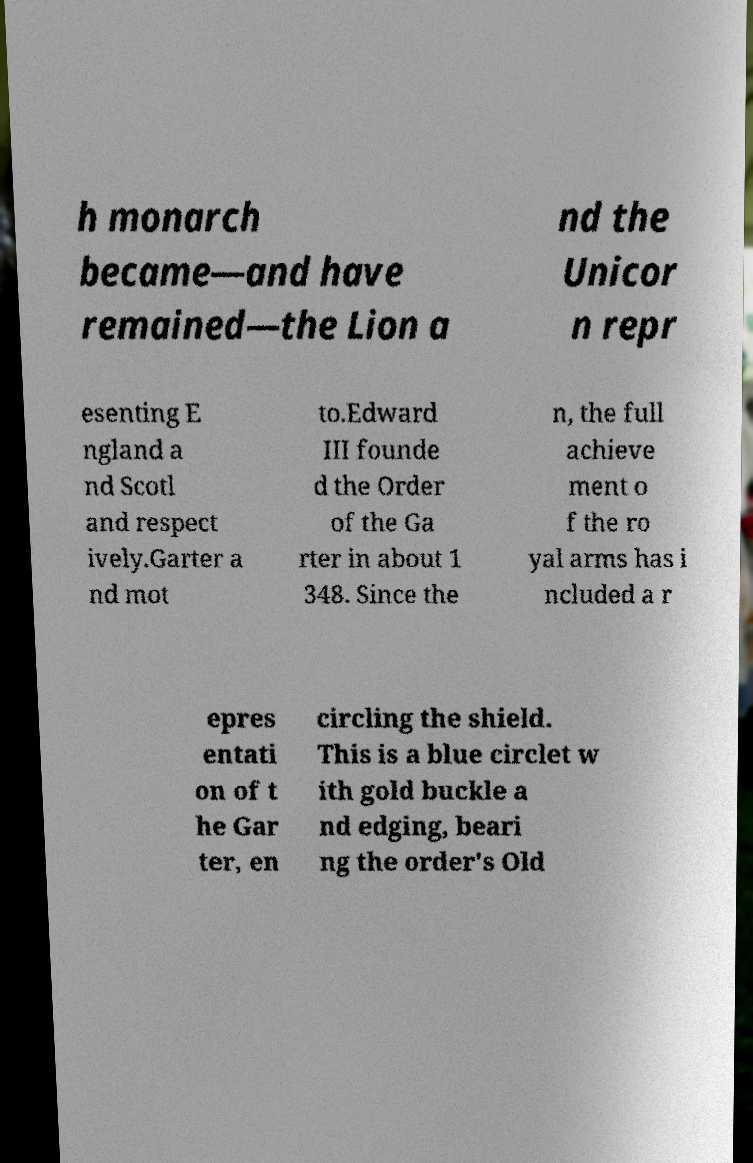There's text embedded in this image that I need extracted. Can you transcribe it verbatim? h monarch became—and have remained—the Lion a nd the Unicor n repr esenting E ngland a nd Scotl and respect ively.Garter a nd mot to.Edward III founde d the Order of the Ga rter in about 1 348. Since the n, the full achieve ment o f the ro yal arms has i ncluded a r epres entati on of t he Gar ter, en circling the shield. This is a blue circlet w ith gold buckle a nd edging, beari ng the order's Old 